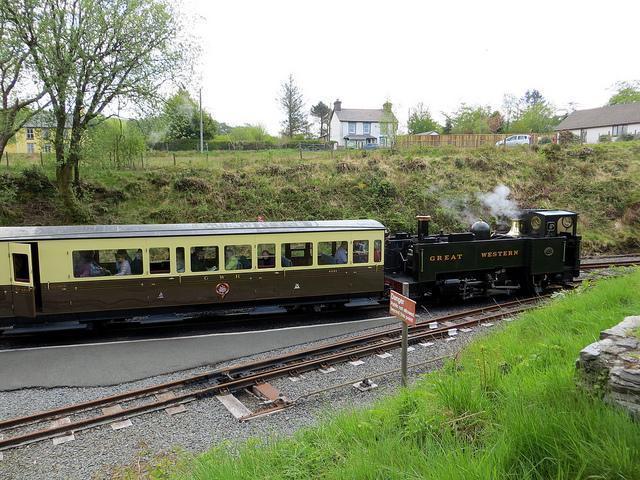How many chairs are there?
Give a very brief answer. 0. 